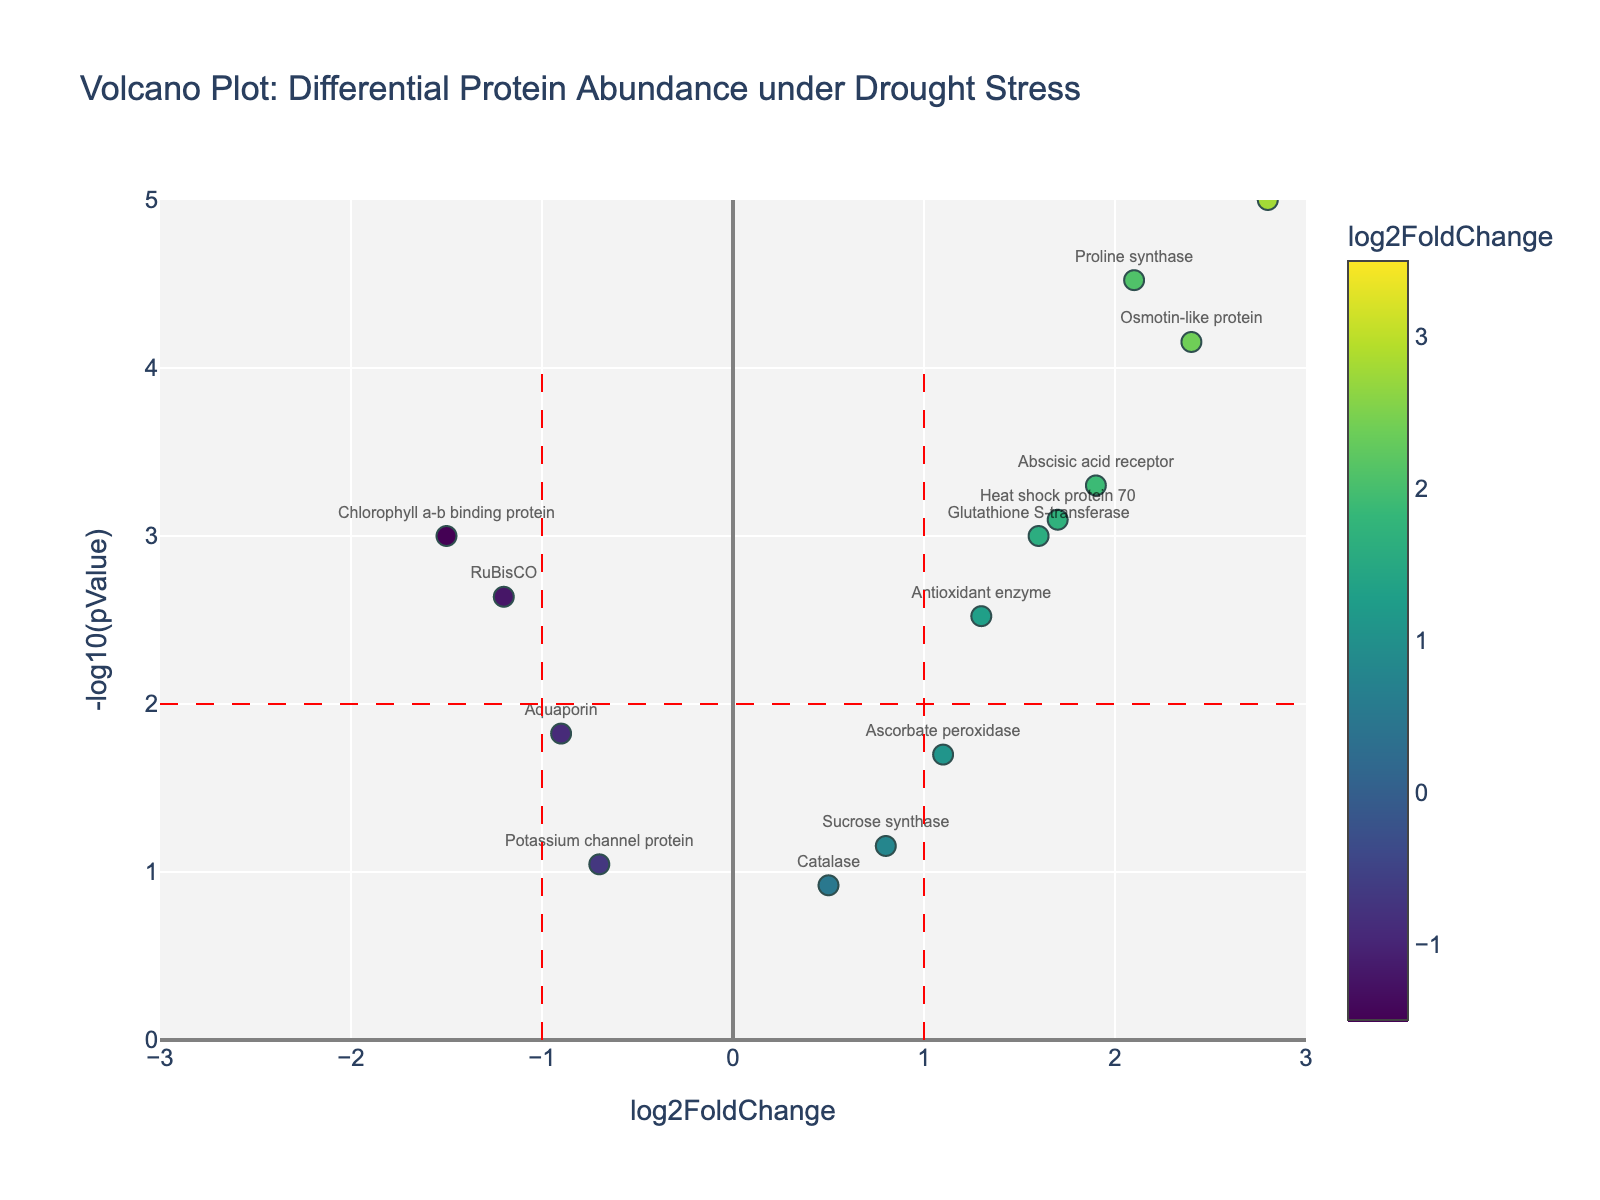what's the title of the plot? The title of the plot is usually located at the top center of the figure. It provides a brief description of what the plot is about. In this case, the title reads "Volcano Plot: Differential Protein Abundance under Drought Stress".
Answer: Volcano Plot: Differential Protein Abundance under Drought Stress how many proteins have a log2FoldChange greater than 2? To answer this question, identify data points with a log2FoldChange value greater than 2 on the x-axis. There are three proteins that meet this criterion: Dehydrin, LEA protein, and Proline synthase.
Answer: 3 which protein has the lowest p-value? The p-value is represented on the y-axis as -log10(pValue), where higher values indicate lower p-values. The highest point on the y-axis represents the lowest p-value. In this plot, the LEA protein has the highest -log10(pValue), indicating the lowest p-value.
Answer: LEA protein which proteins are colored more towards the green end of the colorscale? Proteins towards the green end of the colorscale have lower log2FoldChange values. In this case, proteins like Aquaporin and Potassium channel protein are closer to the green end of the colorscale.
Answer: Aquaporin, Potassium channel protein what are the x-axis and y-axis labels? The x-axis label indicates what is plotted horizontally and reads "log2FoldChange". The y-axis label indicates what is plotted vertically and reads "-log10(pValue)".
Answer: log2FoldChange, -log10(pValue) how many proteins are significantly upregulated under drought stress? Significantly upregulated proteins have a log2FoldChange greater than 1 and a -log10(pValue) greater than 2. Identifying these proteins: Dehydrin, LEA protein, Proline synthase, Abscisic acid receptor, and Osmotin-like protein meet these criteria.
Answer: 5 which protein has the highest log2FoldChange value? To find the protein with the highest log2FoldChange value, look for the data point farthest to the right on the x-axis. The LEA protein has the highest log2FoldChange value of 3.5.
Answer: LEA protein are there more significantly upregulated proteins or significantly downregulated proteins? First, count the number of significantly upregulated proteins (log2FoldChange > 1 and -log10(pValue) > 2) and the number of significantly downregulated proteins (log2FoldChange < -1 and -log10(pValue) > 2). There are 5 significantly upregulated and 2 significantly downregulated proteins.
Answer: More significantly upregulated proteins which protein exhibits both a high log2FoldChange and a high p-value? A high log2FoldChange is indicated by a value far from zero, and a high p-value is indicated by a low -log10(pValue). Sucrose synthase shows a log2FoldChange of 0.8 (high) and is positioned low on the y-axis, suggesting a higher p-value.
Answer: Sucrose synthase 